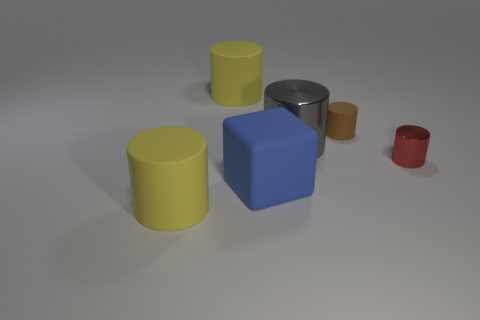Can you describe the materials of the objects shown? Certainly! The objects exhibit a variety of materials based on their appearance. The large blue and small brown objects seem to have a matte texture, indicative of a plastic or painted wooden material. The large yellow object, as well as its smaller counterpart, appears to be glossy, suggesting either polished metal or a ceramic composition. The tiny red object also has a high gloss, implying a similar composition or a lacquered finish. 